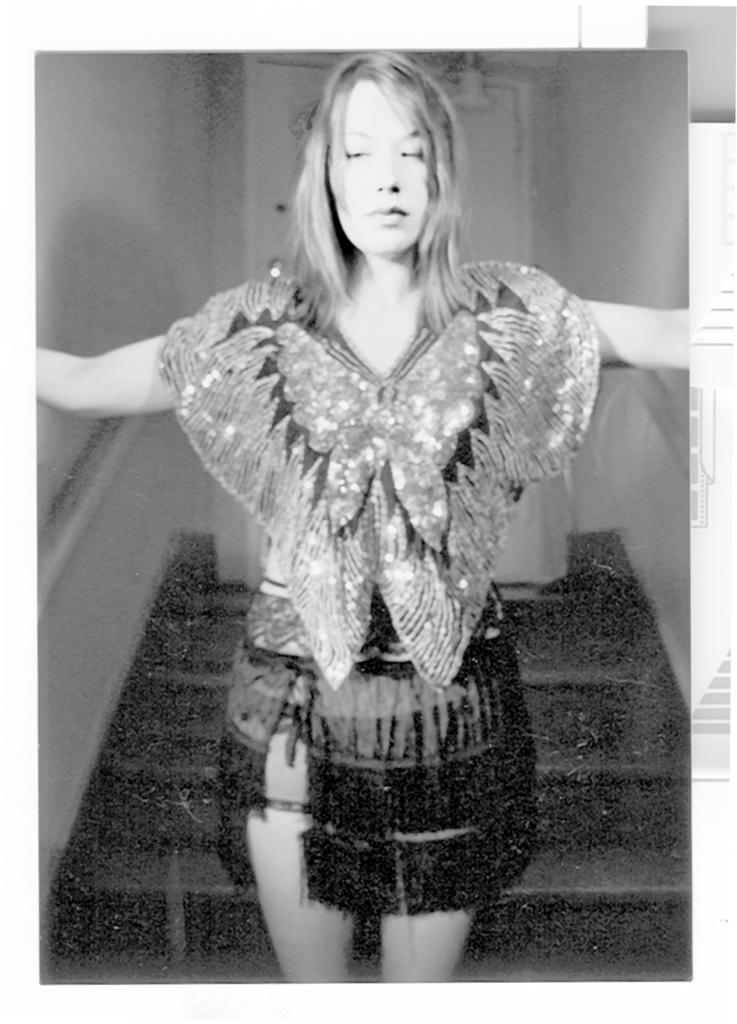Who is present in the image? There is a woman in the image. What is the woman wearing? The woman is wearing a dress. Where is the woman located in the image? The woman is standing near stairs. What can be seen in the background of the image? There is a door visible in the background of the image. What is on the right side of the image? There is a wall on the right side of the image. How many balls are being juggled by the deer in the image? There is no deer or balls present in the image. 